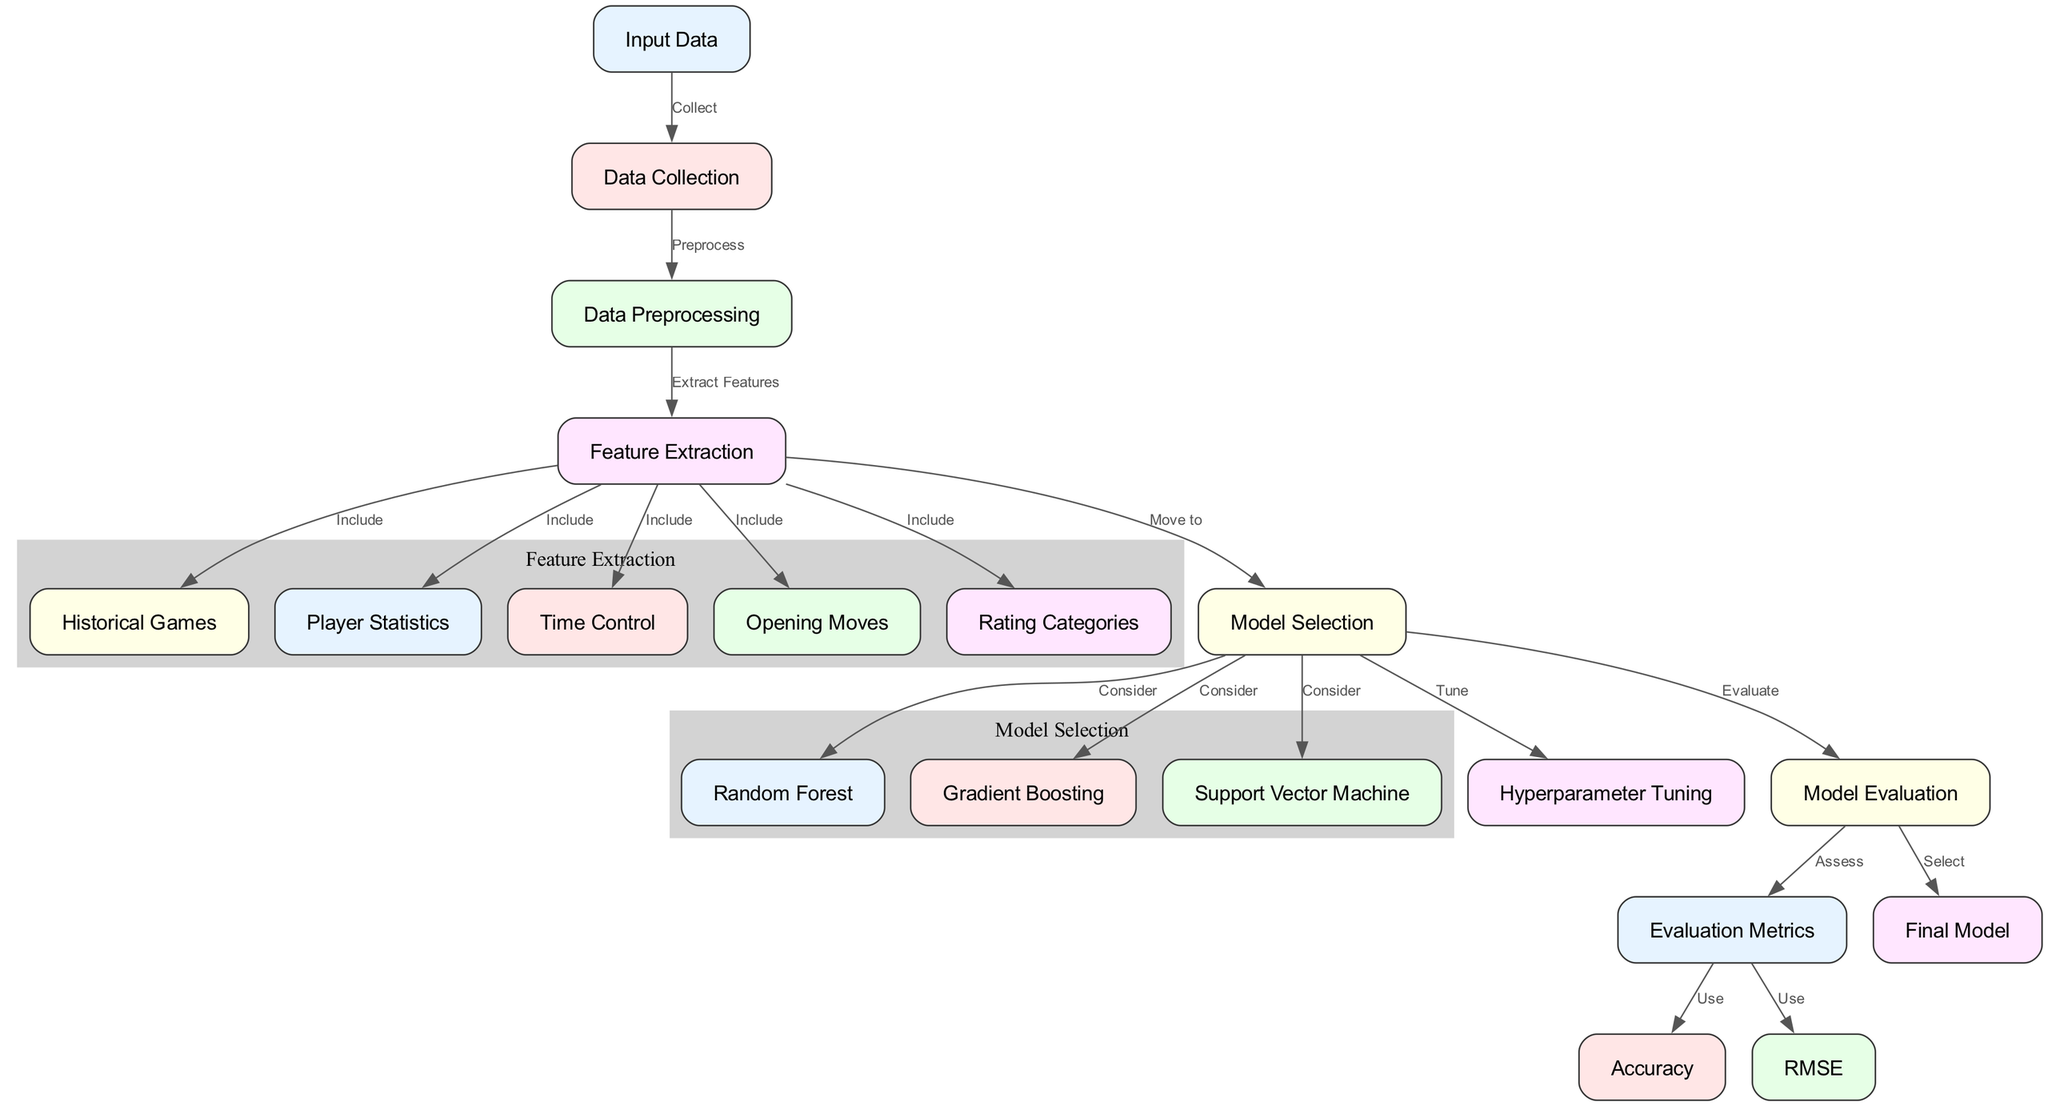What is the first step in the diagram? The diagram begins with the "Input Data" node, which indicates that the process starts with collecting input data before any other step occurs.
Answer: Input Data How many edges are in the diagram? Counting the connections between nodes (edges), the diagram contains a total of 15 edges that denote relationships and flow between various steps in the process.
Answer: 15 What nodes are included in the feature extraction process? The feature extraction process includes "Historical Games," "Player Statistics," "Time Control," "Opening Moves," and "Rating Categories," all associated as inputs for model selection.
Answer: Historical Games, Player Statistics, Time Control, Opening Moves, Rating Categories Which model selection methods are proposed in the diagram? The diagram suggests three model selection methods: "Random Forest," "Gradient Boosting," and "Support Vector Machine," offering options to choose from for predicting Elo ratings.
Answer: Random Forest, Gradient Boosting, Support Vector Machine What comes after hyperparameter tuning in the diagram? After the "Hyperparameter Tuning" step, the next action is "Model Evaluation," where the tuned model is evaluated for performance metrics before final selection.
Answer: Model Evaluation What evaluation metrics are used in the diagram? The evaluation metrics specified in the diagram are "Accuracy" and "RMSE," which are assessed to determine the effectiveness of the proposed models.
Answer: Accuracy, RMSE Which node represents the final output of the model selection process? The "Final Model" node signifies the end product of the model selection and evaluation process, indicating the choice of the best-performing model based on previous steps.
Answer: Final Model What is the role of the data preprocessing node? The "Data Preprocessing" node serves to prepare and clean the collected data, transforming it into a suitable format for subsequent feature extraction.
Answer: Preprocess What action is taken from the model selection node to the evaluation metrics? The action taken is "Assess," meaning that evaluation metrics like accuracy and RMSE are calculated to measure the performance of the model selected in the model selection phase.
Answer: Assess 